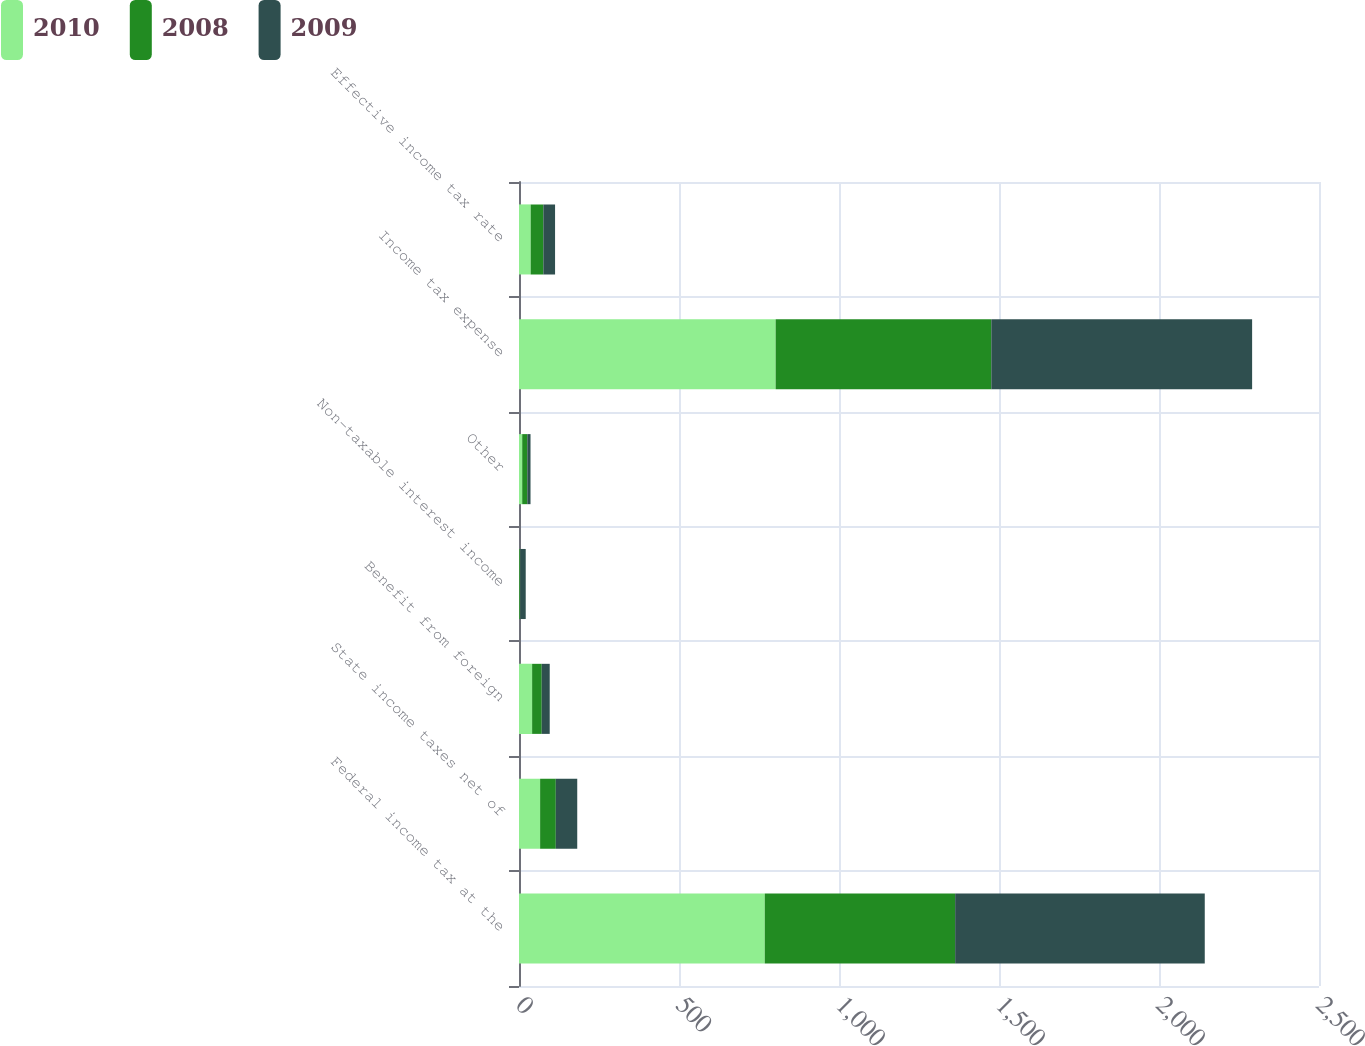<chart> <loc_0><loc_0><loc_500><loc_500><stacked_bar_chart><ecel><fcel>Federal income tax at the<fcel>State income taxes net of<fcel>Benefit from foreign<fcel>Non-taxable interest income<fcel>Other<fcel>Income tax expense<fcel>Effective income tax rate<nl><fcel>2010<fcel>768<fcel>66<fcel>41<fcel>1<fcel>10<fcel>802<fcel>36.5<nl><fcel>2008<fcel>595<fcel>49<fcel>30<fcel>3<fcel>16<fcel>674<fcel>39.6<nl><fcel>2009<fcel>780<fcel>67<fcel>25<fcel>17<fcel>10<fcel>815<fcel>36.6<nl></chart> 